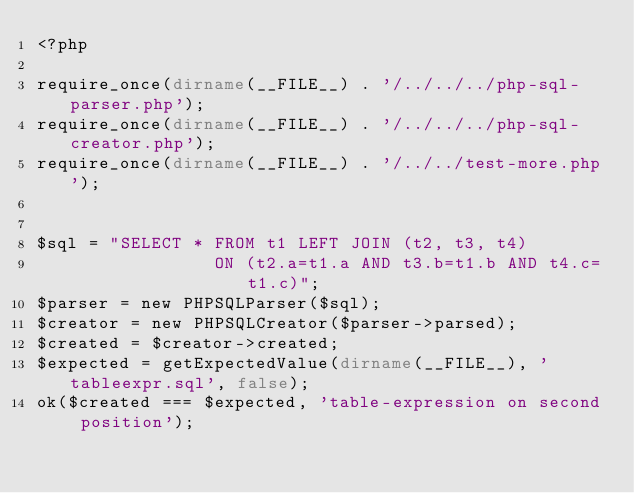Convert code to text. <code><loc_0><loc_0><loc_500><loc_500><_PHP_><?php

require_once(dirname(__FILE__) . '/../../../php-sql-parser.php');
require_once(dirname(__FILE__) . '/../../../php-sql-creator.php');
require_once(dirname(__FILE__) . '/../../test-more.php');


$sql = "SELECT * FROM t1 LEFT JOIN (t2, t3, t4)
                 ON (t2.a=t1.a AND t3.b=t1.b AND t4.c=t1.c)";
$parser = new PHPSQLParser($sql);
$creator = new PHPSQLCreator($parser->parsed);
$created = $creator->created;
$expected = getExpectedValue(dirname(__FILE__), 'tableexpr.sql', false);
ok($created === $expected, 'table-expression on second position');
</code> 